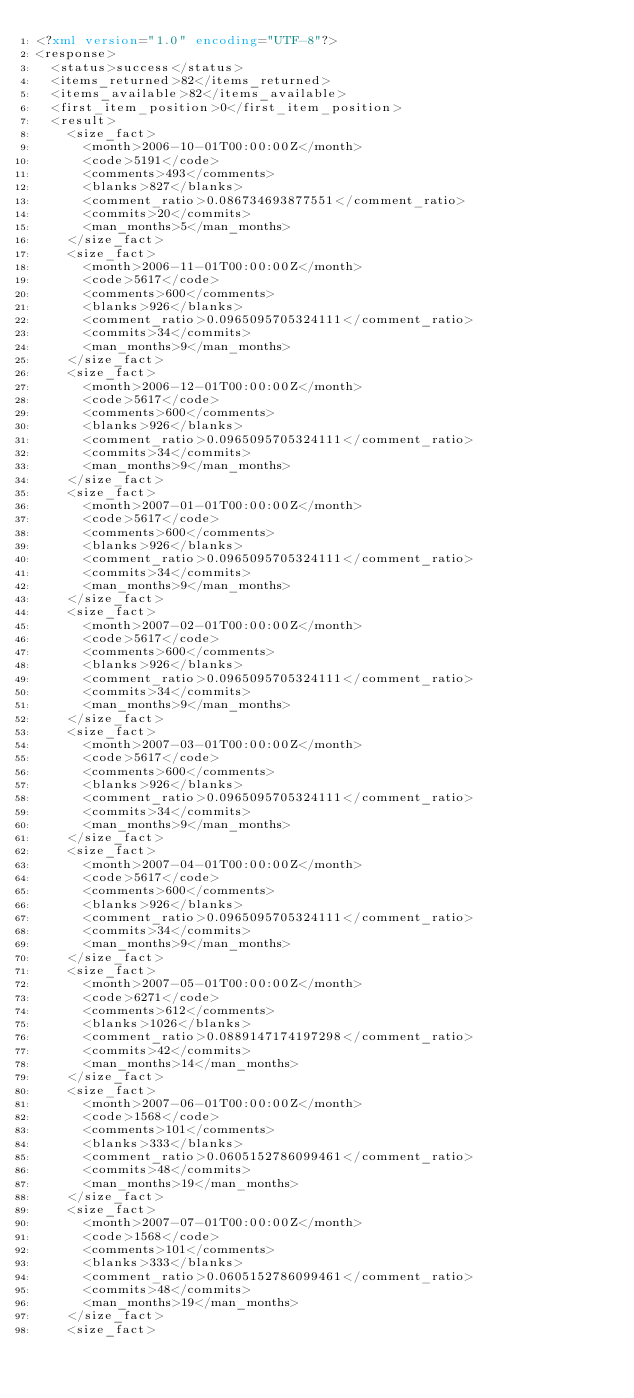Convert code to text. <code><loc_0><loc_0><loc_500><loc_500><_XML_><?xml version="1.0" encoding="UTF-8"?>
<response>
  <status>success</status>
  <items_returned>82</items_returned>
  <items_available>82</items_available>
  <first_item_position>0</first_item_position>
  <result>
    <size_fact>
      <month>2006-10-01T00:00:00Z</month>
      <code>5191</code>
      <comments>493</comments>
      <blanks>827</blanks>
      <comment_ratio>0.086734693877551</comment_ratio>
      <commits>20</commits>
      <man_months>5</man_months>
    </size_fact>
    <size_fact>
      <month>2006-11-01T00:00:00Z</month>
      <code>5617</code>
      <comments>600</comments>
      <blanks>926</blanks>
      <comment_ratio>0.0965095705324111</comment_ratio>
      <commits>34</commits>
      <man_months>9</man_months>
    </size_fact>
    <size_fact>
      <month>2006-12-01T00:00:00Z</month>
      <code>5617</code>
      <comments>600</comments>
      <blanks>926</blanks>
      <comment_ratio>0.0965095705324111</comment_ratio>
      <commits>34</commits>
      <man_months>9</man_months>
    </size_fact>
    <size_fact>
      <month>2007-01-01T00:00:00Z</month>
      <code>5617</code>
      <comments>600</comments>
      <blanks>926</blanks>
      <comment_ratio>0.0965095705324111</comment_ratio>
      <commits>34</commits>
      <man_months>9</man_months>
    </size_fact>
    <size_fact>
      <month>2007-02-01T00:00:00Z</month>
      <code>5617</code>
      <comments>600</comments>
      <blanks>926</blanks>
      <comment_ratio>0.0965095705324111</comment_ratio>
      <commits>34</commits>
      <man_months>9</man_months>
    </size_fact>
    <size_fact>
      <month>2007-03-01T00:00:00Z</month>
      <code>5617</code>
      <comments>600</comments>
      <blanks>926</blanks>
      <comment_ratio>0.0965095705324111</comment_ratio>
      <commits>34</commits>
      <man_months>9</man_months>
    </size_fact>
    <size_fact>
      <month>2007-04-01T00:00:00Z</month>
      <code>5617</code>
      <comments>600</comments>
      <blanks>926</blanks>
      <comment_ratio>0.0965095705324111</comment_ratio>
      <commits>34</commits>
      <man_months>9</man_months>
    </size_fact>
    <size_fact>
      <month>2007-05-01T00:00:00Z</month>
      <code>6271</code>
      <comments>612</comments>
      <blanks>1026</blanks>
      <comment_ratio>0.0889147174197298</comment_ratio>
      <commits>42</commits>
      <man_months>14</man_months>
    </size_fact>
    <size_fact>
      <month>2007-06-01T00:00:00Z</month>
      <code>1568</code>
      <comments>101</comments>
      <blanks>333</blanks>
      <comment_ratio>0.0605152786099461</comment_ratio>
      <commits>48</commits>
      <man_months>19</man_months>
    </size_fact>
    <size_fact>
      <month>2007-07-01T00:00:00Z</month>
      <code>1568</code>
      <comments>101</comments>
      <blanks>333</blanks>
      <comment_ratio>0.0605152786099461</comment_ratio>
      <commits>48</commits>
      <man_months>19</man_months>
    </size_fact>
    <size_fact></code> 